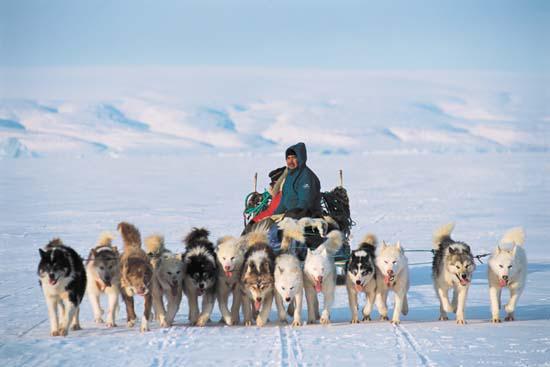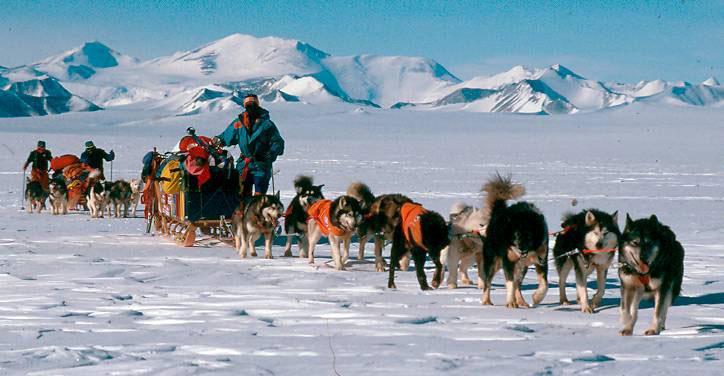The first image is the image on the left, the second image is the image on the right. Evaluate the accuracy of this statement regarding the images: "In the left image, dogs are moving forward.". Is it true? Answer yes or no. Yes. 